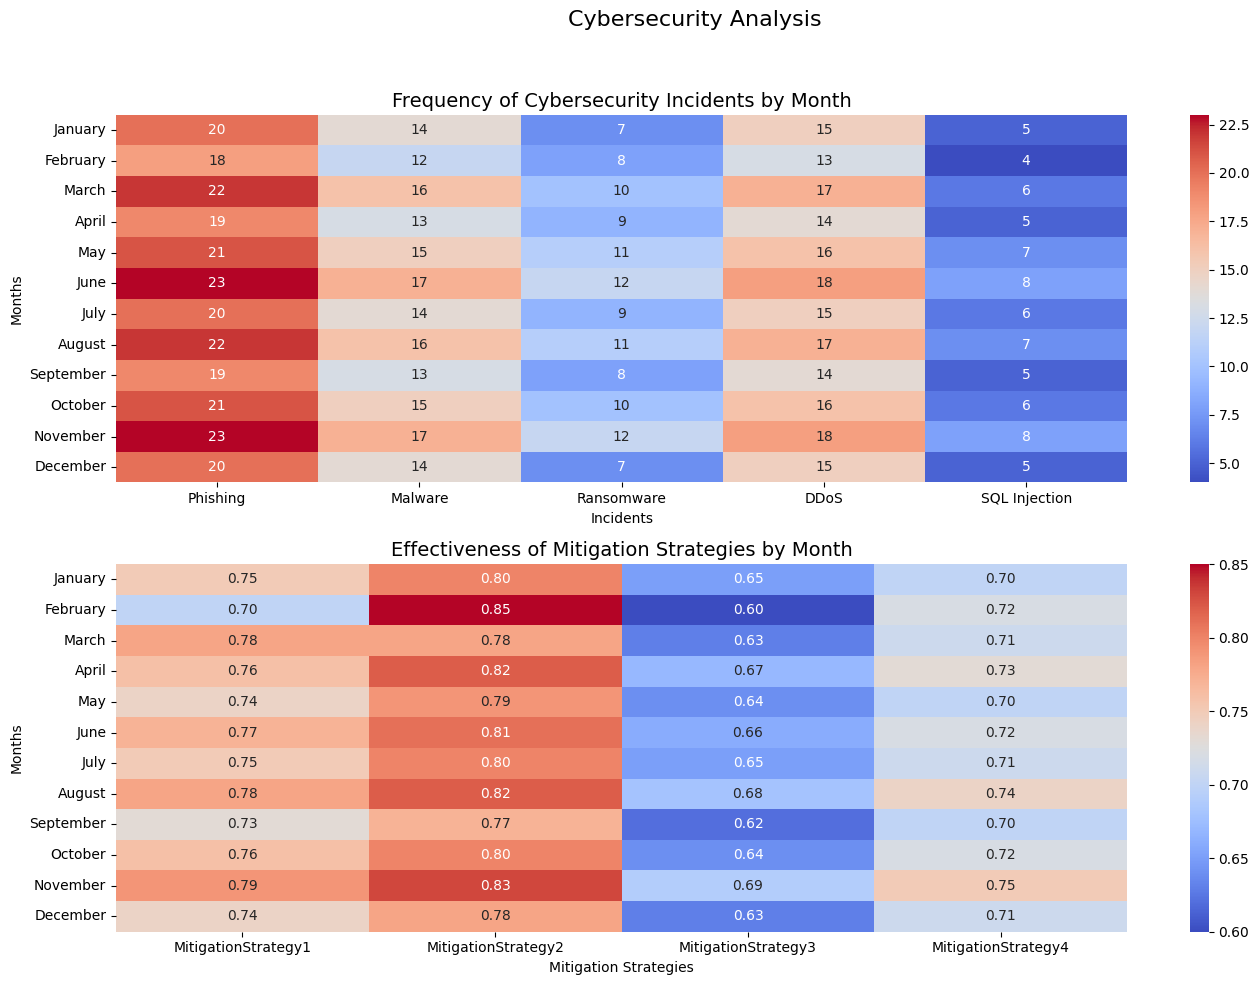Which month had the highest frequency of malware incidents? Look at the heatmap for the frequency of cybersecurity incidents and find the month with the darkest red shade in the 'Malware' column. The darkest red indicates the highest number of incidents.
Answer: November Which mitigation strategy was the least effective in December? Check the heatmap for the effectiveness of mitigation strategies and locate the 'December' row. Find the column with the lowest value (lightest shade of red).
Answer: MitigationStrategy3 What is the sum of phishing incidents in February and March? Locate the 'Phishing' column in the incidents heatmap and find the values for February and March. Sum these values: 18 (February) + 22 (March) = 40
Answer: 40 In which month was MitigationStrategy2 most effective? Look at the mitigation heatmap and find the highest value in the 'MitigationStrategy2' column. The darkest shade of red represents the highest effectiveness.
Answer: February Compare the effectiveness of MitigationStrategy1 and MitigationStrategy3 in July. Which one was more effective? Find the values for 'MitigationStrategy1' and 'MitigationStrategy3' in the 'July' row of the mitigation heatmap. Compare these values: MitigationStrategy1 (0.75) vs. MitigationStrategy3 (0.65). Since 0.75 is greater, MitigationStrategy1 was more effective.
Answer: MitigationStrategy1 Which type of cyber incident had the most frequency in October? Look at the October row in the incident heatmap and find the column with the darkest red shade. This indicates the highest frequency of incidents.
Answer: Malware Calculate the average effectiveness of MitigationStrategy4 between May and August. Locate the 'MitigationStrategy4' column for the months May, June, July, and August. Sum these values (0.70 + 0.72 + 0.71 + 0.74) = 2.87 and then divide by the number of months (4): 2.87/4 = 0.7175.
Answer: 0.7175 Did the frequency of DDoS incidents increase, decrease, or remain stable from June to July? Check the 'DDoS' column for June (18) and July (15). Compare the values to see if they increased, decreased, or stayed the same.
Answer: Decrease What is the difference in the number of SQL Injection incidents between March and June? Find the 'SQL Injection' values for March (6) and June (8). Calculate the difference: 8 - 6 = 2
Answer: 2 What is the total frequency of ransomware incidents for the year? Sum the values of the 'Ransomware' column for all months: 7 + 8 + 10 + 9 + 11 + 12 + 9 + 11 + 8 + 10 + 12 + 7 = 114
Answer: 114 